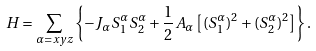<formula> <loc_0><loc_0><loc_500><loc_500>H = \sum _ { \alpha = x y z } \left \{ - J _ { \alpha } S ^ { \alpha } _ { 1 } S ^ { \alpha } _ { 2 } + \frac { 1 } { 2 } A _ { \alpha } \left [ ( S ^ { \alpha } _ { 1 } ) ^ { 2 } + ( S ^ { \alpha } _ { 2 } ) ^ { 2 } \right ] \right \} .</formula> 